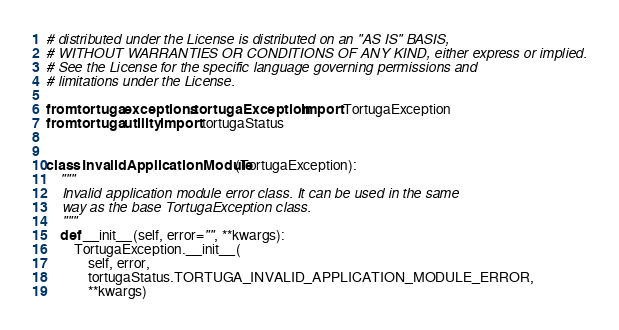<code> <loc_0><loc_0><loc_500><loc_500><_Python_># distributed under the License is distributed on an "AS IS" BASIS,
# WITHOUT WARRANTIES OR CONDITIONS OF ANY KIND, either express or implied.
# See the License for the specific language governing permissions and
# limitations under the License.

from tortuga.exceptions.tortugaException import TortugaException
from tortuga.utility import tortugaStatus


class InvalidApplicationModule(TortugaException):
    """
    Invalid application module error class. It can be used in the same
    way as the base TortugaException class.
    """
    def __init__(self, error="", **kwargs):
        TortugaException.__init__(
            self, error,
            tortugaStatus.TORTUGA_INVALID_APPLICATION_MODULE_ERROR,
            **kwargs)
</code> 